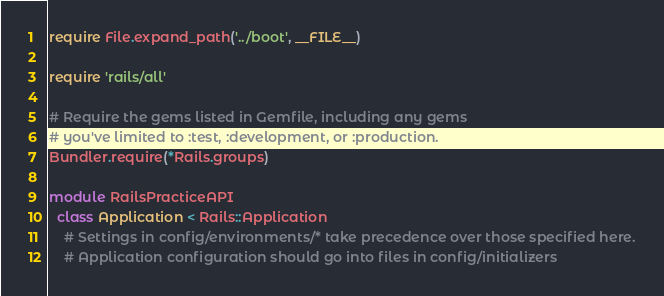<code> <loc_0><loc_0><loc_500><loc_500><_Ruby_>require File.expand_path('../boot', __FILE__)

require 'rails/all'

# Require the gems listed in Gemfile, including any gems
# you've limited to :test, :development, or :production.
Bundler.require(*Rails.groups)

module RailsPracticeAPI
  class Application < Rails::Application
    # Settings in config/environments/* take precedence over those specified here.
    # Application configuration should go into files in config/initializers</code> 